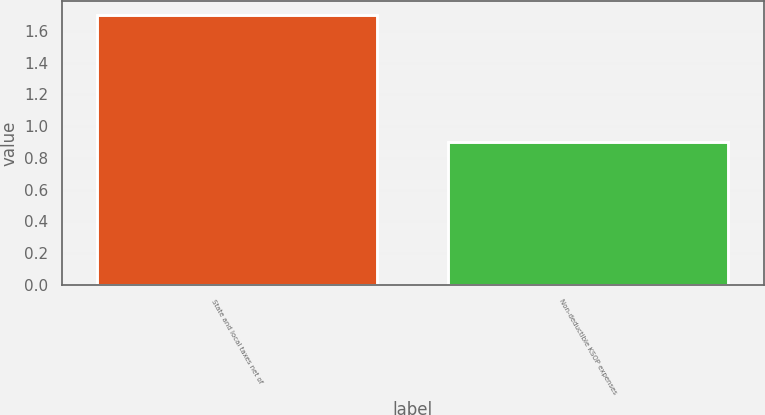<chart> <loc_0><loc_0><loc_500><loc_500><bar_chart><fcel>State and local taxes net of<fcel>Non-deductible KSOP expenses<nl><fcel>1.7<fcel>0.9<nl></chart> 